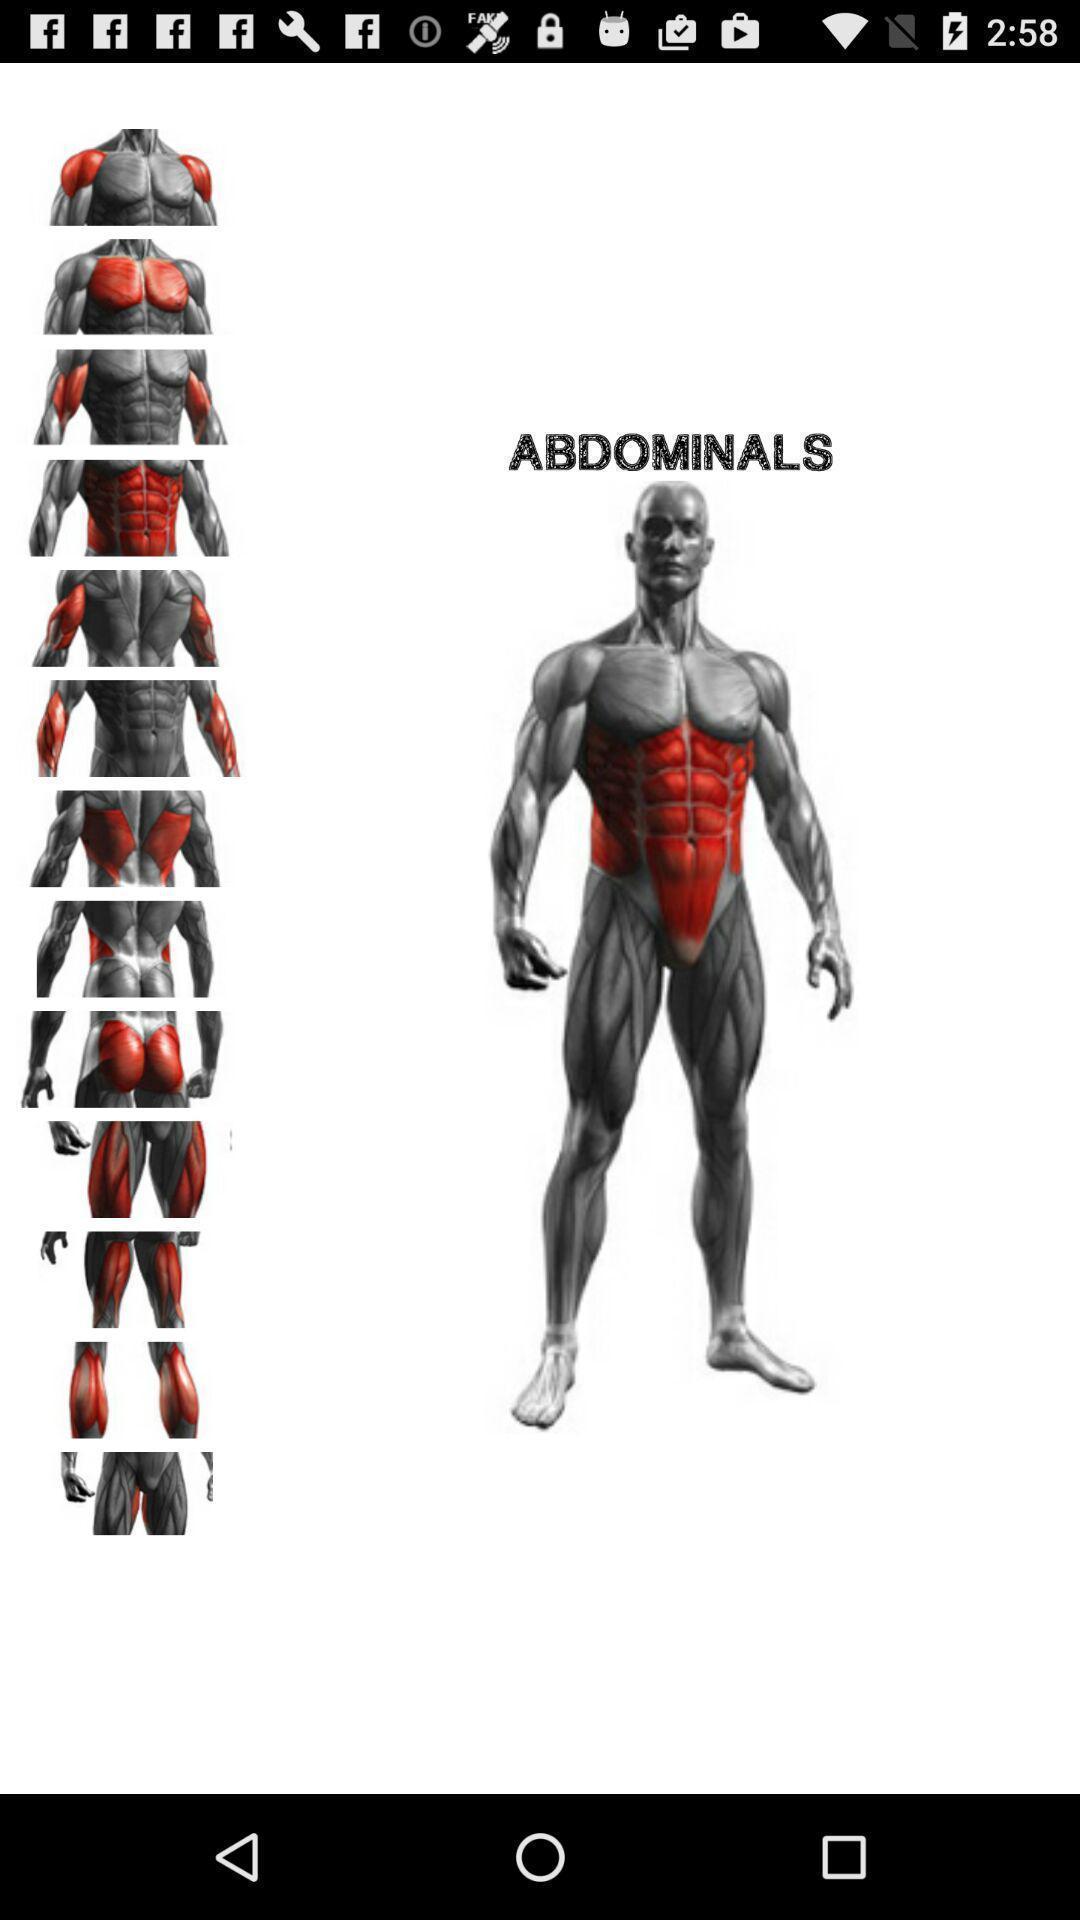Summarize the main components in this picture. Screen showing about a gym training application. 